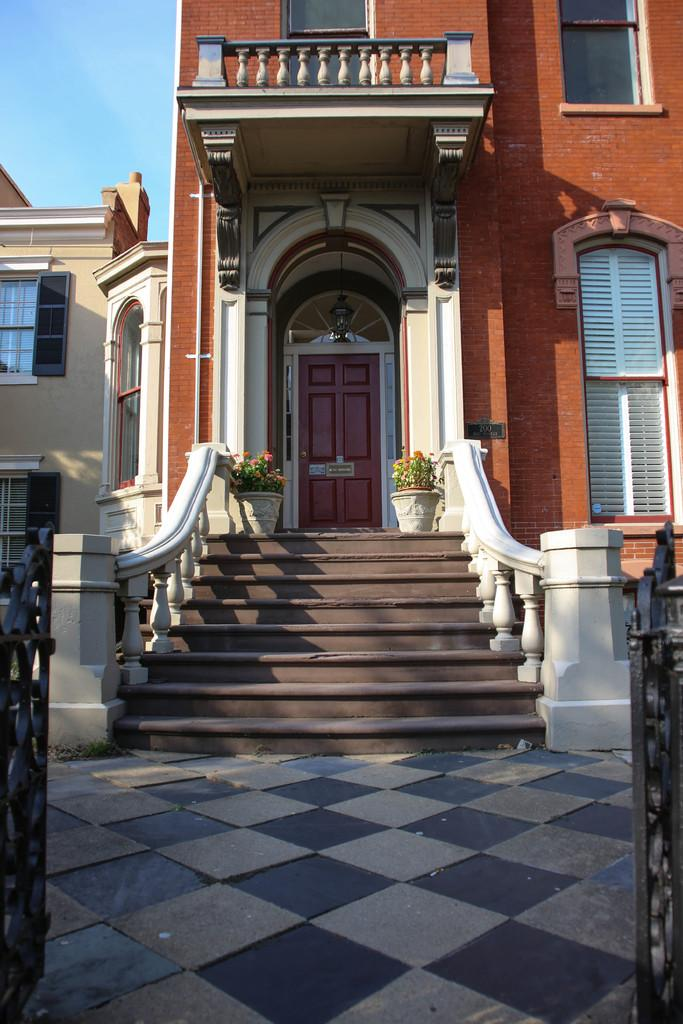What is located in the foreground of the image? There is an opening gate in the foreground of the image. What is in the middle of the image? There is a door in the middle of the image. What type of vegetation is present in the image? There are plants in the image. What architectural feature can be seen in the image? There is a stair in the image. What allows natural light to enter the building in the image? There are windows in the image. What can be seen in the background of the image? The sky is visible in the background of the image. How many children are playing with paper in the image? There are no children or paper present in the image. What type of experience can be gained from the image? The image does not depict an experience; it is a static representation of a scene. 